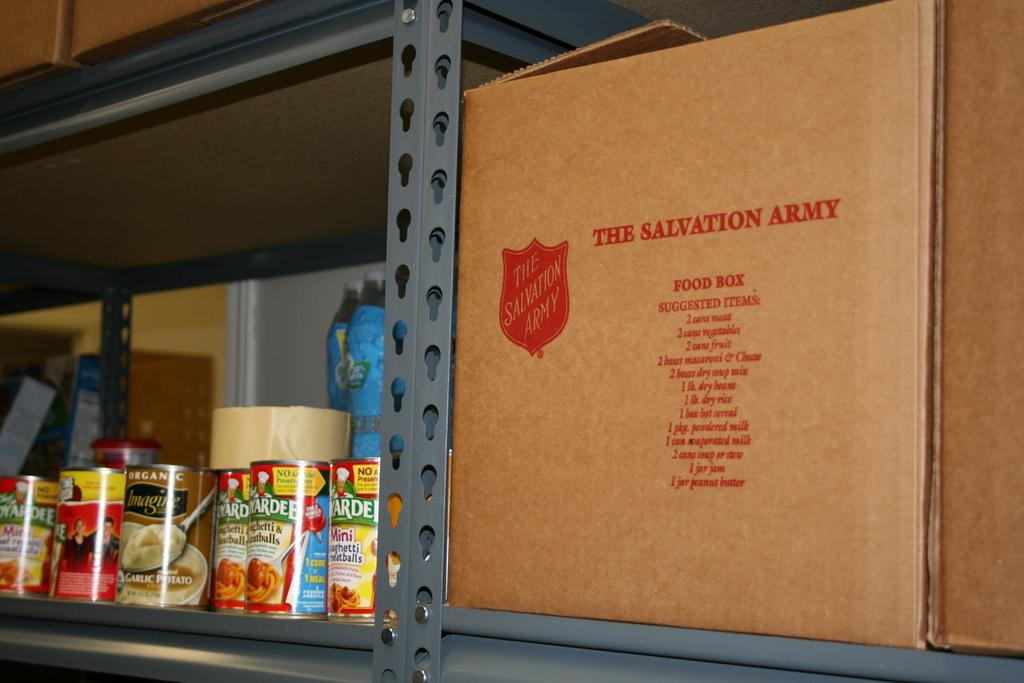<image>
Summarize the visual content of the image. Cans of non perishable foods next to a Salvation Army box. 